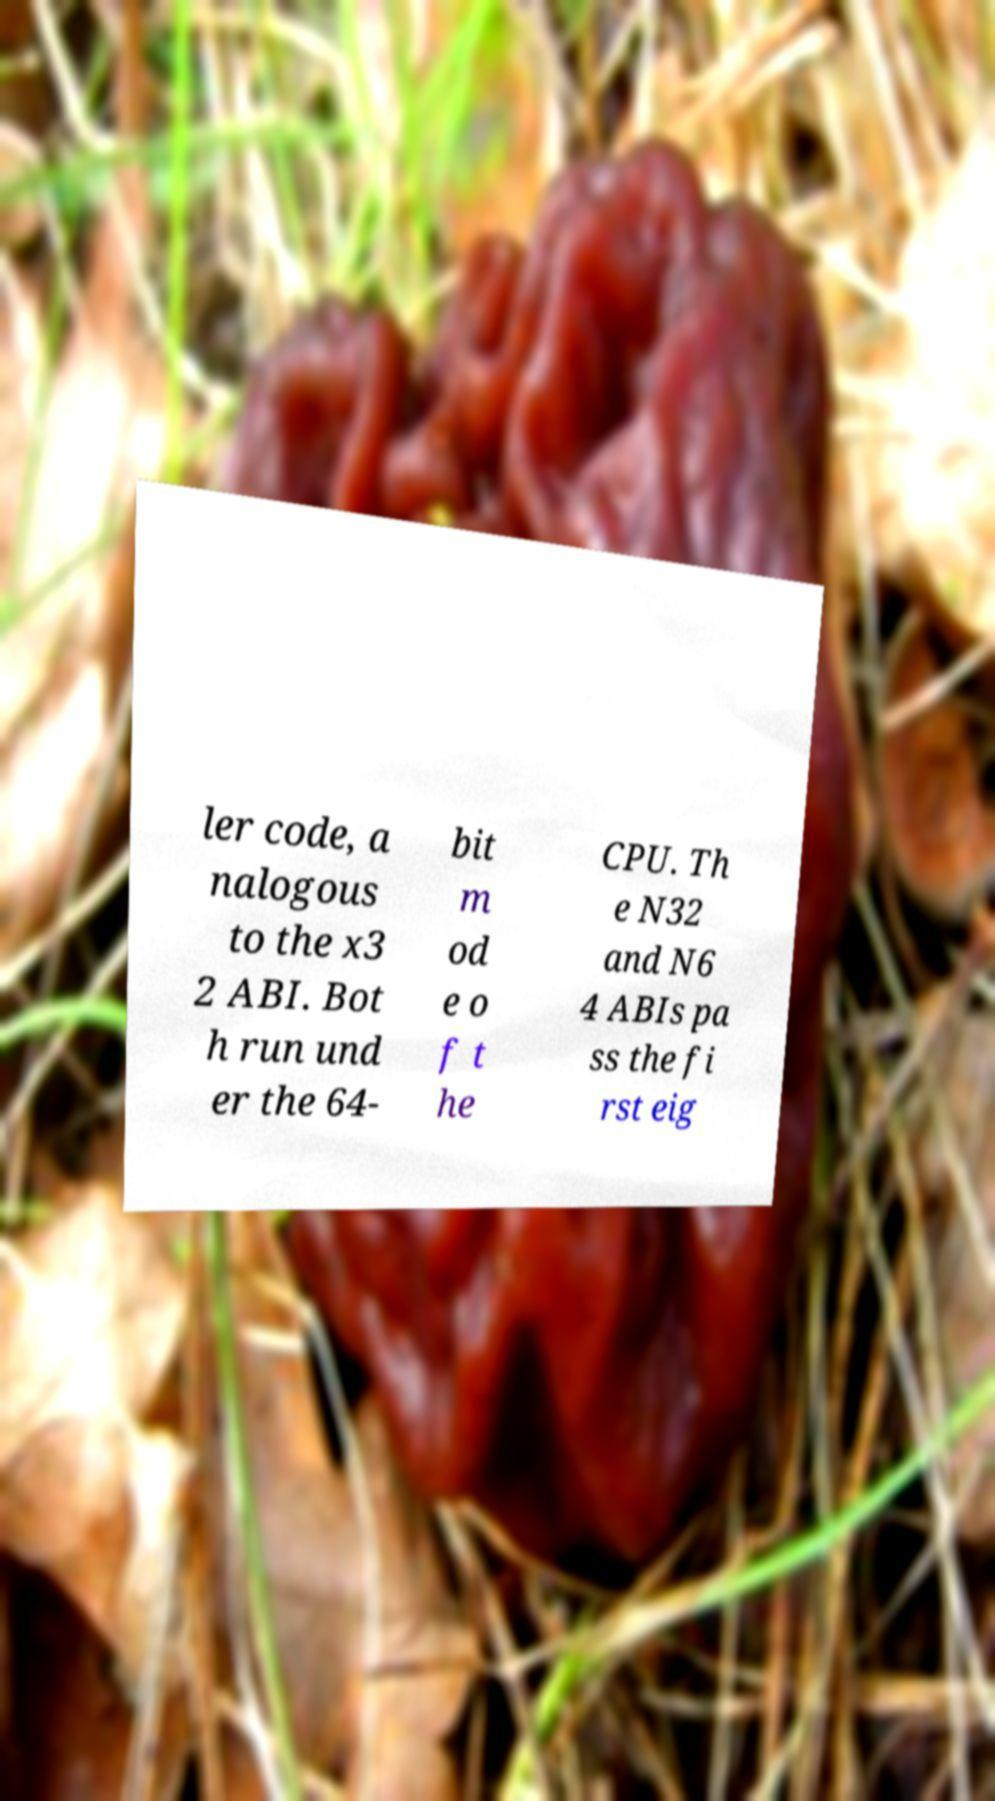I need the written content from this picture converted into text. Can you do that? ler code, a nalogous to the x3 2 ABI. Bot h run und er the 64- bit m od e o f t he CPU. Th e N32 and N6 4 ABIs pa ss the fi rst eig 